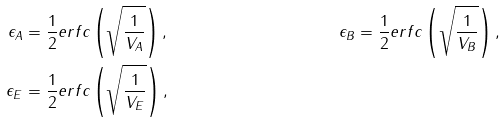<formula> <loc_0><loc_0><loc_500><loc_500>\epsilon _ { A } & = \frac { 1 } { 2 } e r f c \left ( \sqrt { \frac { 1 } { V _ { A } } } \right ) , & \epsilon _ { B } & = \frac { 1 } { 2 } e r f c \left ( \sqrt { \frac { 1 } { V _ { B } } } \right ) , & \\ \epsilon _ { E } & = \frac { 1 } { 2 } e r f c \left ( \sqrt { \frac { 1 } { V _ { E } } } \right ) ,</formula> 